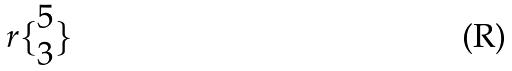Convert formula to latex. <formula><loc_0><loc_0><loc_500><loc_500>r \{ \begin{matrix} 5 \\ 3 \end{matrix} \}</formula> 